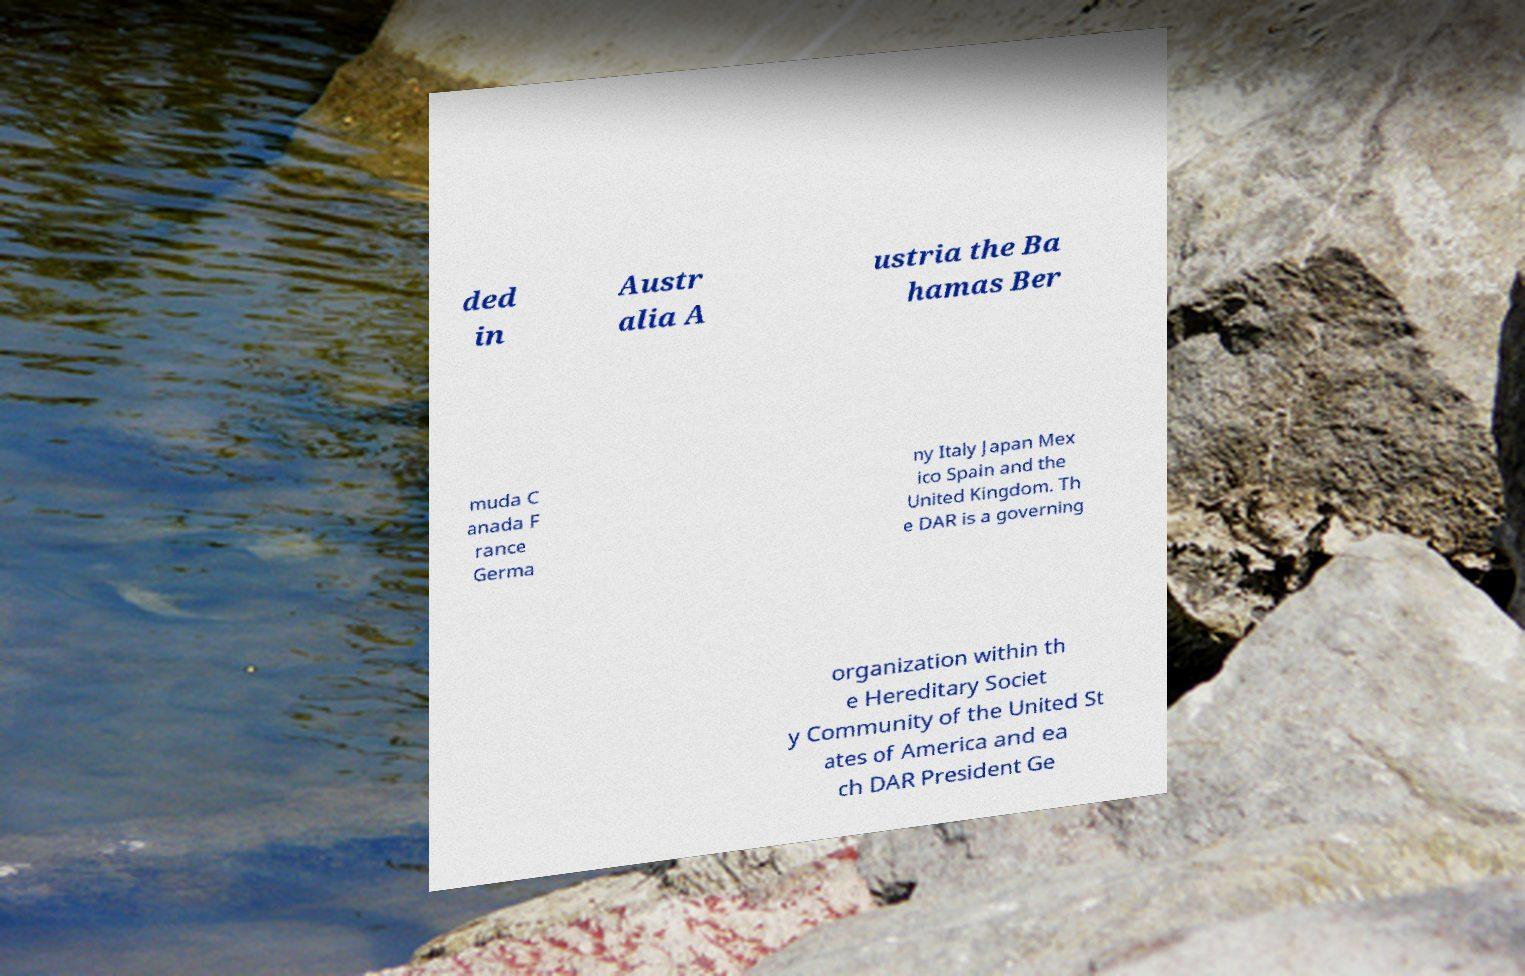Could you extract and type out the text from this image? ded in Austr alia A ustria the Ba hamas Ber muda C anada F rance Germa ny Italy Japan Mex ico Spain and the United Kingdom. Th e DAR is a governing organization within th e Hereditary Societ y Community of the United St ates of America and ea ch DAR President Ge 